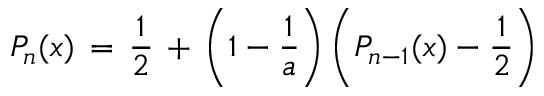Convert formula to latex. <formula><loc_0><loc_0><loc_500><loc_500>P _ { n } ( x ) \, = \, \frac { 1 } { 2 } \, + \, \left ( 1 - \frac { 1 } { a } \right ) \left ( P _ { n - 1 } ( x ) - \frac { 1 } { 2 } \right )</formula> 